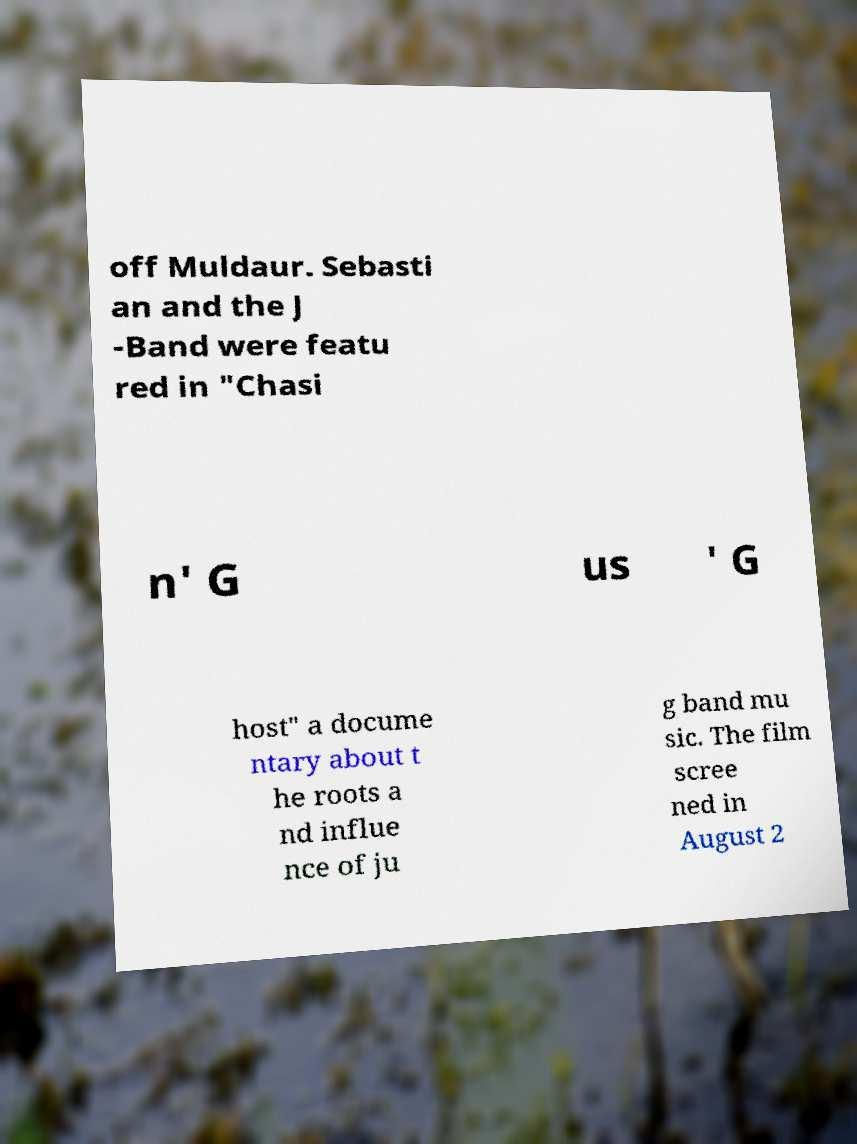Please identify and transcribe the text found in this image. off Muldaur. Sebasti an and the J -Band were featu red in "Chasi n' G us ' G host" a docume ntary about t he roots a nd influe nce of ju g band mu sic. The film scree ned in August 2 